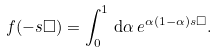<formula> <loc_0><loc_0><loc_500><loc_500>f ( - s \Box ) = \int _ { 0 } ^ { 1 } \, { \mathrm d } \alpha \, { e } ^ { \alpha ( 1 - \alpha ) s \Box } .</formula> 